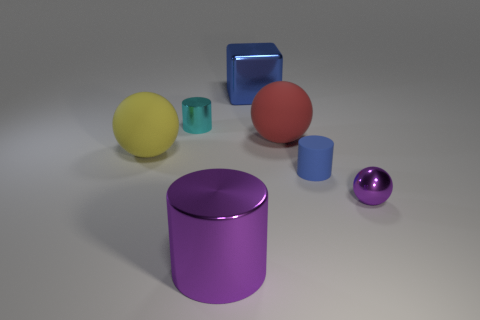Add 1 big cylinders. How many objects exist? 8 Subtract all large spheres. How many spheres are left? 1 Subtract all cylinders. How many objects are left? 4 Subtract all tiny purple shiny objects. Subtract all big gray rubber blocks. How many objects are left? 6 Add 7 purple objects. How many purple objects are left? 9 Add 5 large blue blocks. How many large blue blocks exist? 6 Subtract all purple balls. How many balls are left? 2 Subtract 0 green cubes. How many objects are left? 7 Subtract 1 balls. How many balls are left? 2 Subtract all brown cubes. Subtract all yellow spheres. How many cubes are left? 1 